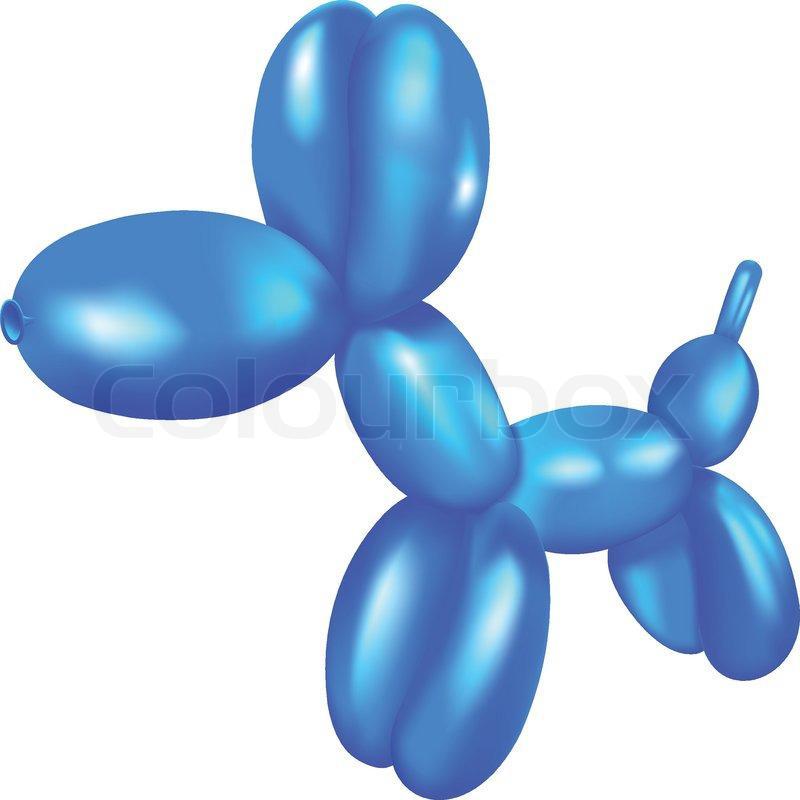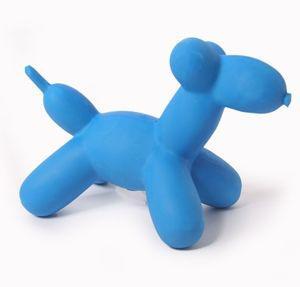The first image is the image on the left, the second image is the image on the right. For the images displayed, is the sentence "Only animal-shaped balloon animals are shown." factually correct? Answer yes or no. Yes. 